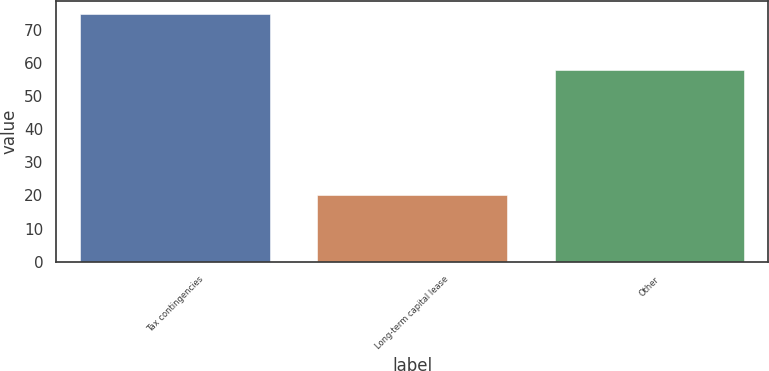<chart> <loc_0><loc_0><loc_500><loc_500><bar_chart><fcel>Tax contingencies<fcel>Long-term capital lease<fcel>Other<nl><fcel>75<fcel>20<fcel>58<nl></chart> 